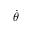<formula> <loc_0><loc_0><loc_500><loc_500>\dot { \theta }</formula> 